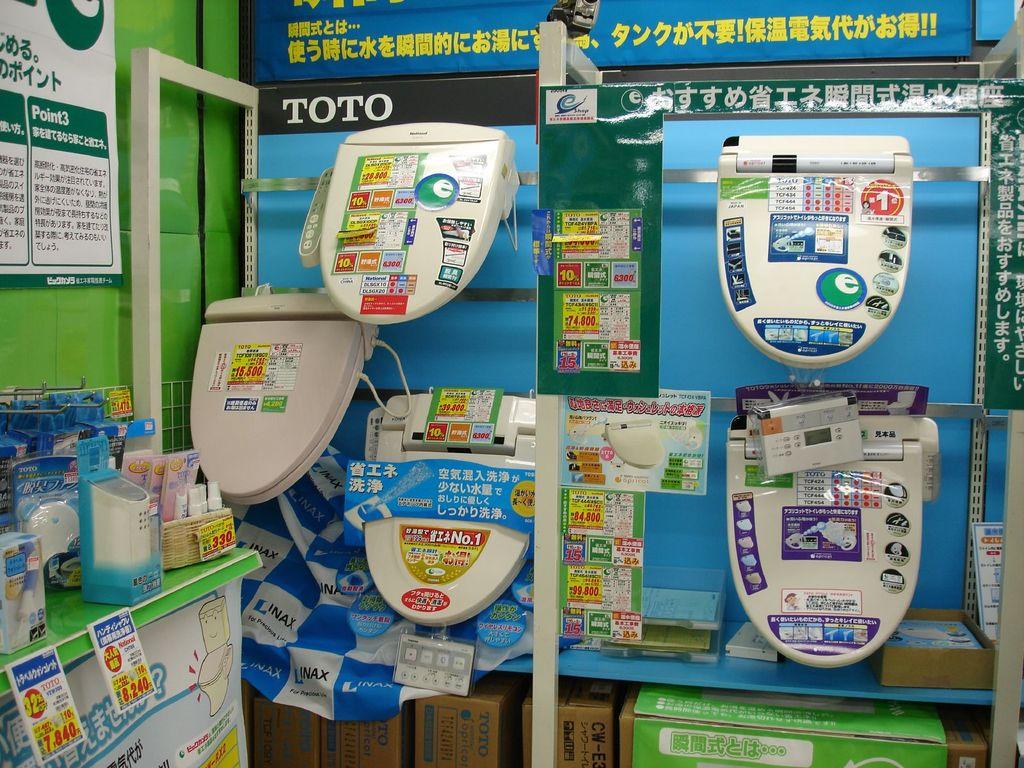What word is written in white with a black background?
Your answer should be very brief. Toto. 